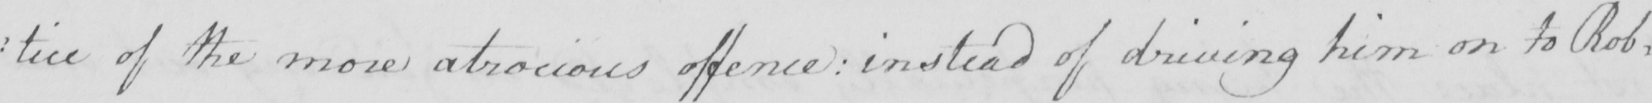What does this handwritten line say? : tice of the more atrocious offence  :  instead of driving him on to Rob= 